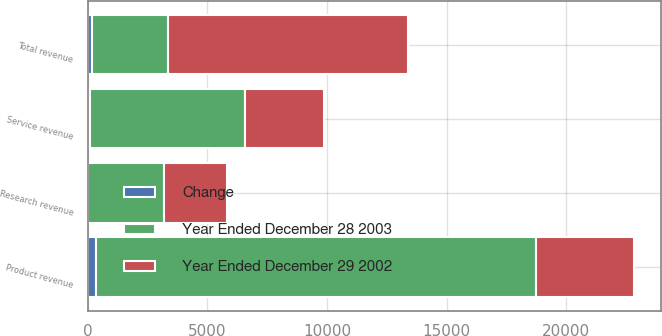<chart> <loc_0><loc_0><loc_500><loc_500><stacked_bar_chart><ecel><fcel>Product revenue<fcel>Service revenue<fcel>Research revenue<fcel>Total revenue<nl><fcel>Year Ended December 28 2003<fcel>18378<fcel>6496<fcel>3161<fcel>3161<nl><fcel>Year Ended December 29 2002<fcel>4103<fcel>3305<fcel>2632<fcel>10040<nl><fcel>Change<fcel>348<fcel>97<fcel>20<fcel>179<nl></chart> 